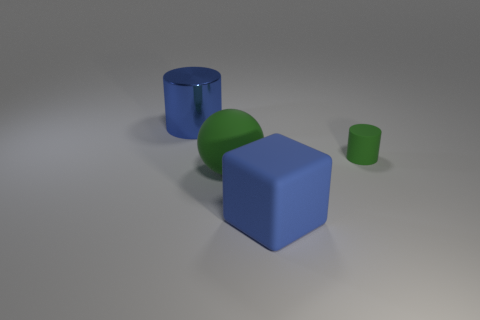Add 4 large gray metal balls. How many objects exist? 8 Subtract all cubes. How many objects are left? 3 Subtract all big green matte things. Subtract all big blue things. How many objects are left? 1 Add 3 green matte cylinders. How many green matte cylinders are left? 4 Add 4 big matte things. How many big matte things exist? 6 Subtract 0 cyan cylinders. How many objects are left? 4 